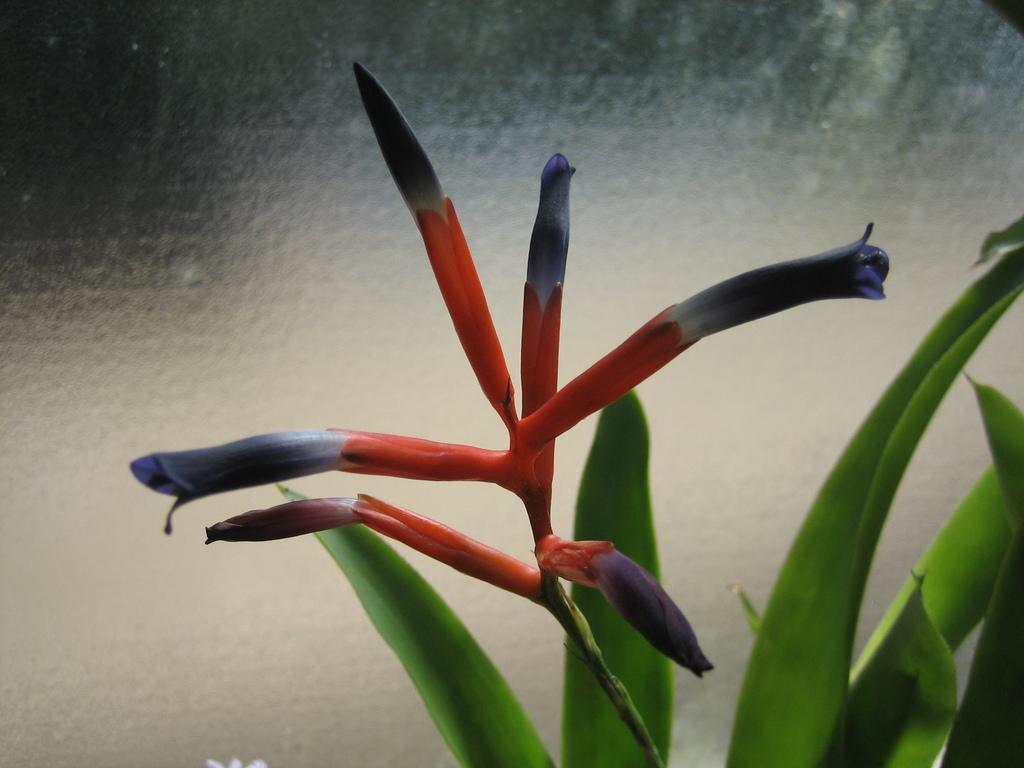What type of plant life can be seen in the image? There are flowers, buds on the stem of a plant, and leaves in the image. Can you describe the stage of growth for the plant in the image? The plant in the image has buds on its stem, indicating that it is in the process of blooming. What other elements are present in the image besides the plant life? There are no other elements mentioned in the provided facts. What type of veil can be seen covering the flowers in the image? There is no veil present in the image; the flowers are not covered. 